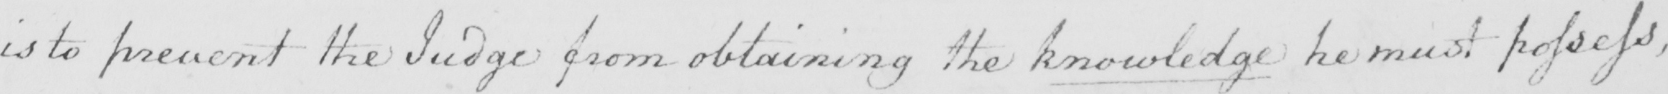Transcribe the text shown in this historical manuscript line. is to prevent the Judge from obtaining the knowledge he must possess , 